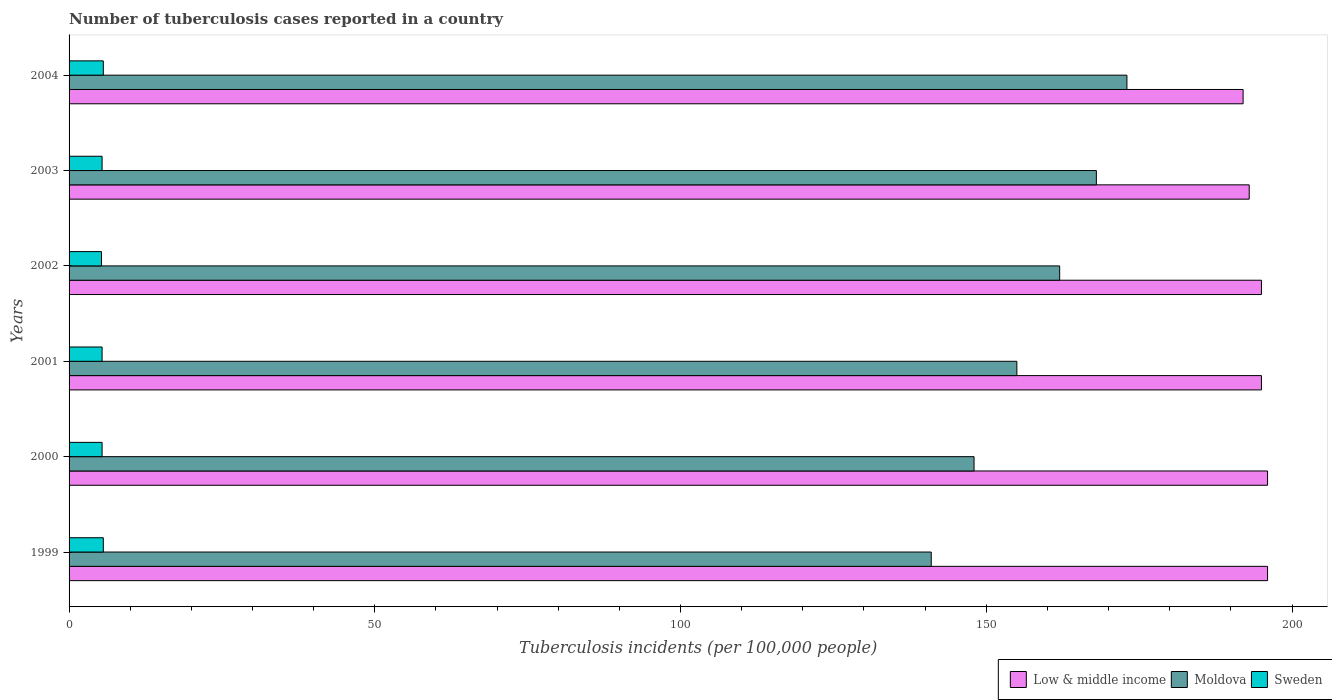How many different coloured bars are there?
Your answer should be compact. 3. How many groups of bars are there?
Your response must be concise. 6. Are the number of bars on each tick of the Y-axis equal?
Your response must be concise. Yes. How many bars are there on the 5th tick from the bottom?
Your answer should be compact. 3. What is the label of the 3rd group of bars from the top?
Provide a succinct answer. 2002. In how many cases, is the number of bars for a given year not equal to the number of legend labels?
Your response must be concise. 0. Across all years, what is the maximum number of tuberculosis cases reported in in Low & middle income?
Provide a succinct answer. 196. Across all years, what is the minimum number of tuberculosis cases reported in in Low & middle income?
Your response must be concise. 192. In which year was the number of tuberculosis cases reported in in Moldova maximum?
Your response must be concise. 2004. What is the total number of tuberculosis cases reported in in Moldova in the graph?
Your response must be concise. 947. What is the difference between the number of tuberculosis cases reported in in Moldova in 2003 and that in 2004?
Your answer should be compact. -5. What is the difference between the number of tuberculosis cases reported in in Low & middle income in 2004 and the number of tuberculosis cases reported in in Sweden in 2000?
Provide a short and direct response. 186.6. What is the average number of tuberculosis cases reported in in Moldova per year?
Your answer should be compact. 157.83. In the year 1999, what is the difference between the number of tuberculosis cases reported in in Low & middle income and number of tuberculosis cases reported in in Moldova?
Your answer should be very brief. 55. What is the ratio of the number of tuberculosis cases reported in in Moldova in 2001 to that in 2003?
Your answer should be compact. 0.92. Is the number of tuberculosis cases reported in in Sweden in 2003 less than that in 2004?
Offer a very short reply. Yes. What is the difference between the highest and the second highest number of tuberculosis cases reported in in Moldova?
Your response must be concise. 5. What is the difference between the highest and the lowest number of tuberculosis cases reported in in Sweden?
Make the answer very short. 0.3. Is the sum of the number of tuberculosis cases reported in in Moldova in 2000 and 2001 greater than the maximum number of tuberculosis cases reported in in Sweden across all years?
Give a very brief answer. Yes. Is it the case that in every year, the sum of the number of tuberculosis cases reported in in Sweden and number of tuberculosis cases reported in in Moldova is greater than the number of tuberculosis cases reported in in Low & middle income?
Ensure brevity in your answer.  No. Are all the bars in the graph horizontal?
Offer a very short reply. Yes. How many years are there in the graph?
Offer a terse response. 6. Are the values on the major ticks of X-axis written in scientific E-notation?
Keep it short and to the point. No. Does the graph contain any zero values?
Keep it short and to the point. No. Does the graph contain grids?
Give a very brief answer. No. Where does the legend appear in the graph?
Keep it short and to the point. Bottom right. What is the title of the graph?
Your answer should be compact. Number of tuberculosis cases reported in a country. What is the label or title of the X-axis?
Ensure brevity in your answer.  Tuberculosis incidents (per 100,0 people). What is the label or title of the Y-axis?
Make the answer very short. Years. What is the Tuberculosis incidents (per 100,000 people) of Low & middle income in 1999?
Make the answer very short. 196. What is the Tuberculosis incidents (per 100,000 people) in Moldova in 1999?
Provide a short and direct response. 141. What is the Tuberculosis incidents (per 100,000 people) of Low & middle income in 2000?
Provide a succinct answer. 196. What is the Tuberculosis incidents (per 100,000 people) in Moldova in 2000?
Offer a very short reply. 148. What is the Tuberculosis incidents (per 100,000 people) in Low & middle income in 2001?
Give a very brief answer. 195. What is the Tuberculosis incidents (per 100,000 people) of Moldova in 2001?
Ensure brevity in your answer.  155. What is the Tuberculosis incidents (per 100,000 people) of Low & middle income in 2002?
Offer a terse response. 195. What is the Tuberculosis incidents (per 100,000 people) of Moldova in 2002?
Your answer should be compact. 162. What is the Tuberculosis incidents (per 100,000 people) of Sweden in 2002?
Your answer should be very brief. 5.3. What is the Tuberculosis incidents (per 100,000 people) of Low & middle income in 2003?
Offer a very short reply. 193. What is the Tuberculosis incidents (per 100,000 people) in Moldova in 2003?
Offer a very short reply. 168. What is the Tuberculosis incidents (per 100,000 people) in Low & middle income in 2004?
Give a very brief answer. 192. What is the Tuberculosis incidents (per 100,000 people) of Moldova in 2004?
Keep it short and to the point. 173. Across all years, what is the maximum Tuberculosis incidents (per 100,000 people) in Low & middle income?
Give a very brief answer. 196. Across all years, what is the maximum Tuberculosis incidents (per 100,000 people) in Moldova?
Provide a short and direct response. 173. Across all years, what is the minimum Tuberculosis incidents (per 100,000 people) of Low & middle income?
Provide a short and direct response. 192. Across all years, what is the minimum Tuberculosis incidents (per 100,000 people) in Moldova?
Provide a short and direct response. 141. Across all years, what is the minimum Tuberculosis incidents (per 100,000 people) in Sweden?
Offer a terse response. 5.3. What is the total Tuberculosis incidents (per 100,000 people) in Low & middle income in the graph?
Offer a very short reply. 1167. What is the total Tuberculosis incidents (per 100,000 people) in Moldova in the graph?
Offer a terse response. 947. What is the total Tuberculosis incidents (per 100,000 people) of Sweden in the graph?
Give a very brief answer. 32.7. What is the difference between the Tuberculosis incidents (per 100,000 people) in Low & middle income in 1999 and that in 2000?
Give a very brief answer. 0. What is the difference between the Tuberculosis incidents (per 100,000 people) of Moldova in 1999 and that in 2000?
Your response must be concise. -7. What is the difference between the Tuberculosis incidents (per 100,000 people) in Low & middle income in 1999 and that in 2001?
Offer a very short reply. 1. What is the difference between the Tuberculosis incidents (per 100,000 people) of Moldova in 1999 and that in 2002?
Offer a terse response. -21. What is the difference between the Tuberculosis incidents (per 100,000 people) in Moldova in 1999 and that in 2003?
Keep it short and to the point. -27. What is the difference between the Tuberculosis incidents (per 100,000 people) in Moldova in 1999 and that in 2004?
Provide a short and direct response. -32. What is the difference between the Tuberculosis incidents (per 100,000 people) in Moldova in 2000 and that in 2001?
Provide a short and direct response. -7. What is the difference between the Tuberculosis incidents (per 100,000 people) in Sweden in 2000 and that in 2001?
Keep it short and to the point. 0. What is the difference between the Tuberculosis incidents (per 100,000 people) in Low & middle income in 2000 and that in 2002?
Provide a short and direct response. 1. What is the difference between the Tuberculosis incidents (per 100,000 people) in Sweden in 2000 and that in 2002?
Provide a short and direct response. 0.1. What is the difference between the Tuberculosis incidents (per 100,000 people) in Low & middle income in 2000 and that in 2003?
Ensure brevity in your answer.  3. What is the difference between the Tuberculosis incidents (per 100,000 people) of Sweden in 2000 and that in 2003?
Your response must be concise. 0. What is the difference between the Tuberculosis incidents (per 100,000 people) of Low & middle income in 2001 and that in 2002?
Offer a very short reply. 0. What is the difference between the Tuberculosis incidents (per 100,000 people) of Sweden in 2001 and that in 2002?
Offer a terse response. 0.1. What is the difference between the Tuberculosis incidents (per 100,000 people) of Low & middle income in 2001 and that in 2003?
Keep it short and to the point. 2. What is the difference between the Tuberculosis incidents (per 100,000 people) in Moldova in 2001 and that in 2003?
Your answer should be compact. -13. What is the difference between the Tuberculosis incidents (per 100,000 people) of Moldova in 2001 and that in 2004?
Ensure brevity in your answer.  -18. What is the difference between the Tuberculosis incidents (per 100,000 people) of Low & middle income in 2002 and that in 2003?
Provide a short and direct response. 2. What is the difference between the Tuberculosis incidents (per 100,000 people) in Low & middle income in 2002 and that in 2004?
Your answer should be compact. 3. What is the difference between the Tuberculosis incidents (per 100,000 people) of Sweden in 2002 and that in 2004?
Your answer should be compact. -0.3. What is the difference between the Tuberculosis incidents (per 100,000 people) in Low & middle income in 2003 and that in 2004?
Ensure brevity in your answer.  1. What is the difference between the Tuberculosis incidents (per 100,000 people) of Low & middle income in 1999 and the Tuberculosis incidents (per 100,000 people) of Sweden in 2000?
Your response must be concise. 190.6. What is the difference between the Tuberculosis incidents (per 100,000 people) of Moldova in 1999 and the Tuberculosis incidents (per 100,000 people) of Sweden in 2000?
Give a very brief answer. 135.6. What is the difference between the Tuberculosis incidents (per 100,000 people) of Low & middle income in 1999 and the Tuberculosis incidents (per 100,000 people) of Moldova in 2001?
Keep it short and to the point. 41. What is the difference between the Tuberculosis incidents (per 100,000 people) of Low & middle income in 1999 and the Tuberculosis incidents (per 100,000 people) of Sweden in 2001?
Your answer should be very brief. 190.6. What is the difference between the Tuberculosis incidents (per 100,000 people) in Moldova in 1999 and the Tuberculosis incidents (per 100,000 people) in Sweden in 2001?
Provide a succinct answer. 135.6. What is the difference between the Tuberculosis incidents (per 100,000 people) in Low & middle income in 1999 and the Tuberculosis incidents (per 100,000 people) in Sweden in 2002?
Offer a very short reply. 190.7. What is the difference between the Tuberculosis incidents (per 100,000 people) of Moldova in 1999 and the Tuberculosis incidents (per 100,000 people) of Sweden in 2002?
Your answer should be compact. 135.7. What is the difference between the Tuberculosis incidents (per 100,000 people) of Low & middle income in 1999 and the Tuberculosis incidents (per 100,000 people) of Sweden in 2003?
Your answer should be compact. 190.6. What is the difference between the Tuberculosis incidents (per 100,000 people) in Moldova in 1999 and the Tuberculosis incidents (per 100,000 people) in Sweden in 2003?
Keep it short and to the point. 135.6. What is the difference between the Tuberculosis incidents (per 100,000 people) in Low & middle income in 1999 and the Tuberculosis incidents (per 100,000 people) in Sweden in 2004?
Ensure brevity in your answer.  190.4. What is the difference between the Tuberculosis incidents (per 100,000 people) in Moldova in 1999 and the Tuberculosis incidents (per 100,000 people) in Sweden in 2004?
Keep it short and to the point. 135.4. What is the difference between the Tuberculosis incidents (per 100,000 people) of Low & middle income in 2000 and the Tuberculosis incidents (per 100,000 people) of Sweden in 2001?
Your response must be concise. 190.6. What is the difference between the Tuberculosis incidents (per 100,000 people) in Moldova in 2000 and the Tuberculosis incidents (per 100,000 people) in Sweden in 2001?
Provide a short and direct response. 142.6. What is the difference between the Tuberculosis incidents (per 100,000 people) in Low & middle income in 2000 and the Tuberculosis incidents (per 100,000 people) in Sweden in 2002?
Your response must be concise. 190.7. What is the difference between the Tuberculosis incidents (per 100,000 people) in Moldova in 2000 and the Tuberculosis incidents (per 100,000 people) in Sweden in 2002?
Offer a very short reply. 142.7. What is the difference between the Tuberculosis incidents (per 100,000 people) in Low & middle income in 2000 and the Tuberculosis incidents (per 100,000 people) in Sweden in 2003?
Your answer should be compact. 190.6. What is the difference between the Tuberculosis incidents (per 100,000 people) of Moldova in 2000 and the Tuberculosis incidents (per 100,000 people) of Sweden in 2003?
Provide a succinct answer. 142.6. What is the difference between the Tuberculosis incidents (per 100,000 people) in Low & middle income in 2000 and the Tuberculosis incidents (per 100,000 people) in Sweden in 2004?
Provide a succinct answer. 190.4. What is the difference between the Tuberculosis incidents (per 100,000 people) in Moldova in 2000 and the Tuberculosis incidents (per 100,000 people) in Sweden in 2004?
Your response must be concise. 142.4. What is the difference between the Tuberculosis incidents (per 100,000 people) in Low & middle income in 2001 and the Tuberculosis incidents (per 100,000 people) in Moldova in 2002?
Provide a succinct answer. 33. What is the difference between the Tuberculosis incidents (per 100,000 people) in Low & middle income in 2001 and the Tuberculosis incidents (per 100,000 people) in Sweden in 2002?
Your answer should be compact. 189.7. What is the difference between the Tuberculosis incidents (per 100,000 people) in Moldova in 2001 and the Tuberculosis incidents (per 100,000 people) in Sweden in 2002?
Ensure brevity in your answer.  149.7. What is the difference between the Tuberculosis incidents (per 100,000 people) of Low & middle income in 2001 and the Tuberculosis incidents (per 100,000 people) of Moldova in 2003?
Offer a very short reply. 27. What is the difference between the Tuberculosis incidents (per 100,000 people) of Low & middle income in 2001 and the Tuberculosis incidents (per 100,000 people) of Sweden in 2003?
Provide a short and direct response. 189.6. What is the difference between the Tuberculosis incidents (per 100,000 people) in Moldova in 2001 and the Tuberculosis incidents (per 100,000 people) in Sweden in 2003?
Your response must be concise. 149.6. What is the difference between the Tuberculosis incidents (per 100,000 people) in Low & middle income in 2001 and the Tuberculosis incidents (per 100,000 people) in Moldova in 2004?
Offer a terse response. 22. What is the difference between the Tuberculosis incidents (per 100,000 people) in Low & middle income in 2001 and the Tuberculosis incidents (per 100,000 people) in Sweden in 2004?
Ensure brevity in your answer.  189.4. What is the difference between the Tuberculosis incidents (per 100,000 people) in Moldova in 2001 and the Tuberculosis incidents (per 100,000 people) in Sweden in 2004?
Provide a short and direct response. 149.4. What is the difference between the Tuberculosis incidents (per 100,000 people) in Low & middle income in 2002 and the Tuberculosis incidents (per 100,000 people) in Moldova in 2003?
Offer a very short reply. 27. What is the difference between the Tuberculosis incidents (per 100,000 people) in Low & middle income in 2002 and the Tuberculosis incidents (per 100,000 people) in Sweden in 2003?
Your answer should be compact. 189.6. What is the difference between the Tuberculosis incidents (per 100,000 people) of Moldova in 2002 and the Tuberculosis incidents (per 100,000 people) of Sweden in 2003?
Keep it short and to the point. 156.6. What is the difference between the Tuberculosis incidents (per 100,000 people) in Low & middle income in 2002 and the Tuberculosis incidents (per 100,000 people) in Moldova in 2004?
Provide a succinct answer. 22. What is the difference between the Tuberculosis incidents (per 100,000 people) in Low & middle income in 2002 and the Tuberculosis incidents (per 100,000 people) in Sweden in 2004?
Ensure brevity in your answer.  189.4. What is the difference between the Tuberculosis incidents (per 100,000 people) of Moldova in 2002 and the Tuberculosis incidents (per 100,000 people) of Sweden in 2004?
Make the answer very short. 156.4. What is the difference between the Tuberculosis incidents (per 100,000 people) of Low & middle income in 2003 and the Tuberculosis incidents (per 100,000 people) of Moldova in 2004?
Keep it short and to the point. 20. What is the difference between the Tuberculosis incidents (per 100,000 people) of Low & middle income in 2003 and the Tuberculosis incidents (per 100,000 people) of Sweden in 2004?
Keep it short and to the point. 187.4. What is the difference between the Tuberculosis incidents (per 100,000 people) of Moldova in 2003 and the Tuberculosis incidents (per 100,000 people) of Sweden in 2004?
Give a very brief answer. 162.4. What is the average Tuberculosis incidents (per 100,000 people) of Low & middle income per year?
Your answer should be compact. 194.5. What is the average Tuberculosis incidents (per 100,000 people) in Moldova per year?
Your response must be concise. 157.83. What is the average Tuberculosis incidents (per 100,000 people) of Sweden per year?
Your answer should be compact. 5.45. In the year 1999, what is the difference between the Tuberculosis incidents (per 100,000 people) of Low & middle income and Tuberculosis incidents (per 100,000 people) of Moldova?
Keep it short and to the point. 55. In the year 1999, what is the difference between the Tuberculosis incidents (per 100,000 people) in Low & middle income and Tuberculosis incidents (per 100,000 people) in Sweden?
Ensure brevity in your answer.  190.4. In the year 1999, what is the difference between the Tuberculosis incidents (per 100,000 people) in Moldova and Tuberculosis incidents (per 100,000 people) in Sweden?
Provide a succinct answer. 135.4. In the year 2000, what is the difference between the Tuberculosis incidents (per 100,000 people) of Low & middle income and Tuberculosis incidents (per 100,000 people) of Sweden?
Your response must be concise. 190.6. In the year 2000, what is the difference between the Tuberculosis incidents (per 100,000 people) of Moldova and Tuberculosis incidents (per 100,000 people) of Sweden?
Keep it short and to the point. 142.6. In the year 2001, what is the difference between the Tuberculosis incidents (per 100,000 people) in Low & middle income and Tuberculosis incidents (per 100,000 people) in Moldova?
Ensure brevity in your answer.  40. In the year 2001, what is the difference between the Tuberculosis incidents (per 100,000 people) of Low & middle income and Tuberculosis incidents (per 100,000 people) of Sweden?
Keep it short and to the point. 189.6. In the year 2001, what is the difference between the Tuberculosis incidents (per 100,000 people) in Moldova and Tuberculosis incidents (per 100,000 people) in Sweden?
Provide a short and direct response. 149.6. In the year 2002, what is the difference between the Tuberculosis incidents (per 100,000 people) in Low & middle income and Tuberculosis incidents (per 100,000 people) in Sweden?
Your answer should be very brief. 189.7. In the year 2002, what is the difference between the Tuberculosis incidents (per 100,000 people) of Moldova and Tuberculosis incidents (per 100,000 people) of Sweden?
Keep it short and to the point. 156.7. In the year 2003, what is the difference between the Tuberculosis incidents (per 100,000 people) in Low & middle income and Tuberculosis incidents (per 100,000 people) in Moldova?
Provide a succinct answer. 25. In the year 2003, what is the difference between the Tuberculosis incidents (per 100,000 people) in Low & middle income and Tuberculosis incidents (per 100,000 people) in Sweden?
Offer a very short reply. 187.6. In the year 2003, what is the difference between the Tuberculosis incidents (per 100,000 people) of Moldova and Tuberculosis incidents (per 100,000 people) of Sweden?
Your answer should be very brief. 162.6. In the year 2004, what is the difference between the Tuberculosis incidents (per 100,000 people) of Low & middle income and Tuberculosis incidents (per 100,000 people) of Moldova?
Give a very brief answer. 19. In the year 2004, what is the difference between the Tuberculosis incidents (per 100,000 people) in Low & middle income and Tuberculosis incidents (per 100,000 people) in Sweden?
Your answer should be very brief. 186.4. In the year 2004, what is the difference between the Tuberculosis incidents (per 100,000 people) in Moldova and Tuberculosis incidents (per 100,000 people) in Sweden?
Keep it short and to the point. 167.4. What is the ratio of the Tuberculosis incidents (per 100,000 people) in Low & middle income in 1999 to that in 2000?
Keep it short and to the point. 1. What is the ratio of the Tuberculosis incidents (per 100,000 people) in Moldova in 1999 to that in 2000?
Offer a very short reply. 0.95. What is the ratio of the Tuberculosis incidents (per 100,000 people) of Sweden in 1999 to that in 2000?
Your answer should be compact. 1.04. What is the ratio of the Tuberculosis incidents (per 100,000 people) of Low & middle income in 1999 to that in 2001?
Make the answer very short. 1.01. What is the ratio of the Tuberculosis incidents (per 100,000 people) of Moldova in 1999 to that in 2001?
Ensure brevity in your answer.  0.91. What is the ratio of the Tuberculosis incidents (per 100,000 people) of Moldova in 1999 to that in 2002?
Provide a succinct answer. 0.87. What is the ratio of the Tuberculosis incidents (per 100,000 people) in Sweden in 1999 to that in 2002?
Keep it short and to the point. 1.06. What is the ratio of the Tuberculosis incidents (per 100,000 people) of Low & middle income in 1999 to that in 2003?
Your response must be concise. 1.02. What is the ratio of the Tuberculosis incidents (per 100,000 people) in Moldova in 1999 to that in 2003?
Your answer should be compact. 0.84. What is the ratio of the Tuberculosis incidents (per 100,000 people) in Low & middle income in 1999 to that in 2004?
Give a very brief answer. 1.02. What is the ratio of the Tuberculosis incidents (per 100,000 people) of Moldova in 1999 to that in 2004?
Keep it short and to the point. 0.81. What is the ratio of the Tuberculosis incidents (per 100,000 people) of Sweden in 1999 to that in 2004?
Offer a terse response. 1. What is the ratio of the Tuberculosis incidents (per 100,000 people) of Low & middle income in 2000 to that in 2001?
Keep it short and to the point. 1.01. What is the ratio of the Tuberculosis incidents (per 100,000 people) of Moldova in 2000 to that in 2001?
Provide a short and direct response. 0.95. What is the ratio of the Tuberculosis incidents (per 100,000 people) in Low & middle income in 2000 to that in 2002?
Keep it short and to the point. 1.01. What is the ratio of the Tuberculosis incidents (per 100,000 people) in Moldova in 2000 to that in 2002?
Keep it short and to the point. 0.91. What is the ratio of the Tuberculosis incidents (per 100,000 people) in Sweden in 2000 to that in 2002?
Provide a short and direct response. 1.02. What is the ratio of the Tuberculosis incidents (per 100,000 people) of Low & middle income in 2000 to that in 2003?
Give a very brief answer. 1.02. What is the ratio of the Tuberculosis incidents (per 100,000 people) of Moldova in 2000 to that in 2003?
Offer a terse response. 0.88. What is the ratio of the Tuberculosis incidents (per 100,000 people) in Low & middle income in 2000 to that in 2004?
Provide a succinct answer. 1.02. What is the ratio of the Tuberculosis incidents (per 100,000 people) of Moldova in 2000 to that in 2004?
Make the answer very short. 0.86. What is the ratio of the Tuberculosis incidents (per 100,000 people) of Moldova in 2001 to that in 2002?
Your response must be concise. 0.96. What is the ratio of the Tuberculosis incidents (per 100,000 people) in Sweden in 2001 to that in 2002?
Make the answer very short. 1.02. What is the ratio of the Tuberculosis incidents (per 100,000 people) in Low & middle income in 2001 to that in 2003?
Provide a short and direct response. 1.01. What is the ratio of the Tuberculosis incidents (per 100,000 people) of Moldova in 2001 to that in 2003?
Offer a terse response. 0.92. What is the ratio of the Tuberculosis incidents (per 100,000 people) of Low & middle income in 2001 to that in 2004?
Offer a terse response. 1.02. What is the ratio of the Tuberculosis incidents (per 100,000 people) of Moldova in 2001 to that in 2004?
Keep it short and to the point. 0.9. What is the ratio of the Tuberculosis incidents (per 100,000 people) of Sweden in 2001 to that in 2004?
Give a very brief answer. 0.96. What is the ratio of the Tuberculosis incidents (per 100,000 people) of Low & middle income in 2002 to that in 2003?
Provide a short and direct response. 1.01. What is the ratio of the Tuberculosis incidents (per 100,000 people) of Moldova in 2002 to that in 2003?
Offer a very short reply. 0.96. What is the ratio of the Tuberculosis incidents (per 100,000 people) in Sweden in 2002 to that in 2003?
Give a very brief answer. 0.98. What is the ratio of the Tuberculosis incidents (per 100,000 people) of Low & middle income in 2002 to that in 2004?
Your answer should be very brief. 1.02. What is the ratio of the Tuberculosis incidents (per 100,000 people) of Moldova in 2002 to that in 2004?
Your answer should be compact. 0.94. What is the ratio of the Tuberculosis incidents (per 100,000 people) in Sweden in 2002 to that in 2004?
Your answer should be very brief. 0.95. What is the ratio of the Tuberculosis incidents (per 100,000 people) in Low & middle income in 2003 to that in 2004?
Your answer should be compact. 1.01. What is the ratio of the Tuberculosis incidents (per 100,000 people) of Moldova in 2003 to that in 2004?
Ensure brevity in your answer.  0.97. What is the difference between the highest and the lowest Tuberculosis incidents (per 100,000 people) of Low & middle income?
Give a very brief answer. 4. What is the difference between the highest and the lowest Tuberculosis incidents (per 100,000 people) of Moldova?
Your answer should be compact. 32. What is the difference between the highest and the lowest Tuberculosis incidents (per 100,000 people) of Sweden?
Your response must be concise. 0.3. 